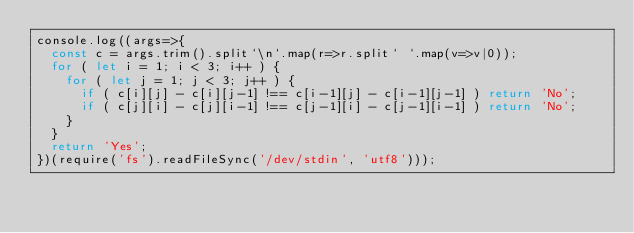Convert code to text. <code><loc_0><loc_0><loc_500><loc_500><_JavaScript_>console.log((args=>{
  const c = args.trim().split`\n`.map(r=>r.split` `.map(v=>v|0));
  for ( let i = 1; i < 3; i++ ) {
    for ( let j = 1; j < 3; j++ ) {
      if ( c[i][j] - c[i][j-1] !== c[i-1][j] - c[i-1][j-1] ) return 'No';
      if ( c[j][i] - c[j][i-1] !== c[j-1][i] - c[j-1][i-1] ) return 'No';
    }
  }
  return 'Yes';
})(require('fs').readFileSync('/dev/stdin', 'utf8')));
</code> 